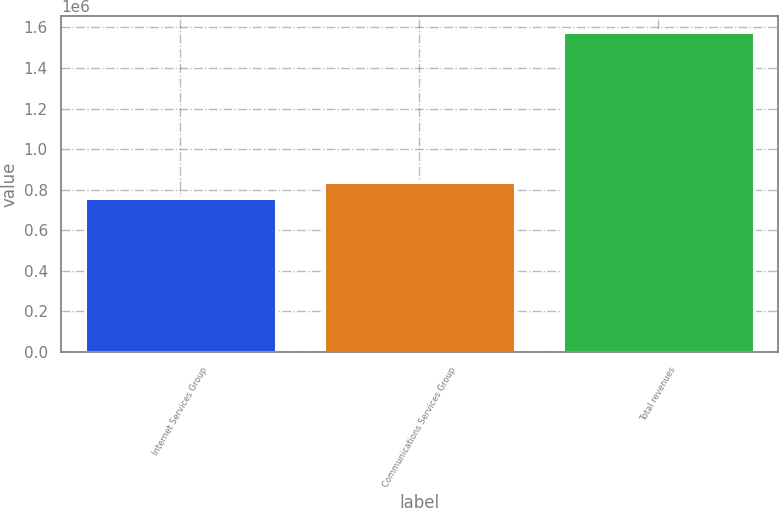Convert chart. <chart><loc_0><loc_0><loc_500><loc_500><bar_chart><fcel>Internet Services Group<fcel>Communications Services Group<fcel>Total revenues<nl><fcel>758763<fcel>840412<fcel>1.57525e+06<nl></chart> 